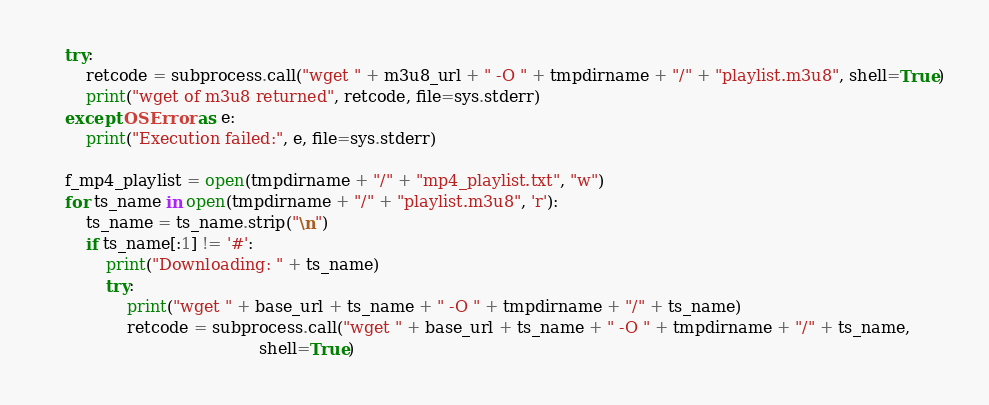<code> <loc_0><loc_0><loc_500><loc_500><_Python_>    try:
        retcode = subprocess.call("wget " + m3u8_url + " -O " + tmpdirname + "/" + "playlist.m3u8", shell=True)
        print("wget of m3u8 returned", retcode, file=sys.stderr)
    except OSError as e:
        print("Execution failed:", e, file=sys.stderr)

    f_mp4_playlist = open(tmpdirname + "/" + "mp4_playlist.txt", "w")
    for ts_name in open(tmpdirname + "/" + "playlist.m3u8", 'r'):
        ts_name = ts_name.strip("\n")
        if ts_name[:1] != '#':
            print("Downloading: " + ts_name)
            try:
                print("wget " + base_url + ts_name + " -O " + tmpdirname + "/" + ts_name)
                retcode = subprocess.call("wget " + base_url + ts_name + " -O " + tmpdirname + "/" + ts_name,
                                          shell=True)</code> 